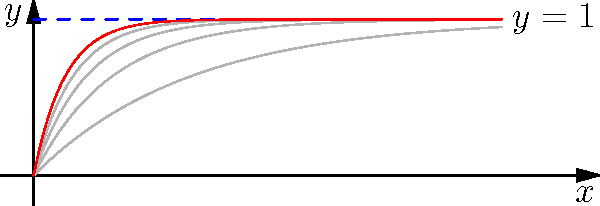Consider the sequence of functions $f_n(x) = 1 - e^{-nx}$ defined on $[0,\infty)$ in a Fréchet space with the topology of uniform convergence on compact subsets. Does this sequence converge to the function $f(x) = 1$? If so, in what sense does it converge? To determine the convergence of the sequence $f_n(x) = 1 - e^{-nx}$ to $f(x) = 1$, we need to follow these steps:

1) First, observe that for any fixed $x > 0$, $\lim_{n \to \infty} f_n(x) = 1 = f(x)$. This suggests pointwise convergence.

2) In a Fréchet space with the topology of uniform convergence on compact subsets, we need to check if the convergence is uniform on any compact subset of $[0,\infty)$.

3) Let $K = [0,M]$ be a compact subset of $[0,\infty)$. We need to show that:
   $$\lim_{n \to \infty} \sup_{x \in K} |f_n(x) - f(x)| = 0$$

4) For $x \in K$:
   $$|f_n(x) - f(x)| = |1 - e^{-nx} - 1| = e^{-nx}$$

5) The maximum value of $e^{-nx}$ on $K$ occurs at $x = 0$, so:
   $$\sup_{x \in K} |f_n(x) - f(x)| = e^{-n \cdot 0} = 1$$

6) As $n \to \infty$, this supremum approaches 0.

7) Therefore, $f_n$ converges uniformly to $f$ on any compact subset of $[0,\infty)$.

8) Since uniform convergence on compact subsets is the defining property of convergence in this Fréchet space, we can conclude that $f_n$ converges to $f$ in the given Fréchet space topology.
Answer: Yes, $f_n$ converges to $f$ in the Fréchet space topology of uniform convergence on compact subsets. 